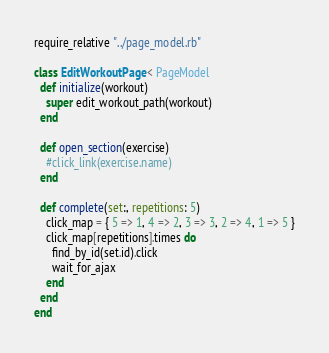Convert code to text. <code><loc_0><loc_0><loc_500><loc_500><_Ruby_>require_relative "../page_model.rb"

class EditWorkoutPage < PageModel
  def initialize(workout)
    super edit_workout_path(workout)
  end

  def open_section(exercise)
    #click_link(exercise.name)
  end

  def complete(set:, repetitions: 5)
    click_map = { 5 => 1, 4 => 2, 3 => 3, 2 => 4, 1 => 5 }
    click_map[repetitions].times do
      find_by_id(set.id).click
      wait_for_ajax
    end
  end
end
</code> 